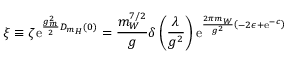Convert formula to latex. <formula><loc_0><loc_0><loc_500><loc_500>\xi \equiv \zeta e ^ { \frac { g _ { m } ^ { 2 } } { 2 } D _ { m _ { H } } ( 0 ) } = \frac { m _ { W } ^ { 7 / 2 } } { g } \delta \left ( \frac { \lambda } { g ^ { 2 } } \right ) e ^ { \frac { 2 \pi m _ { W } } { g ^ { 2 } } \left ( - 2 \epsilon + e ^ { - c } \right ) }</formula> 